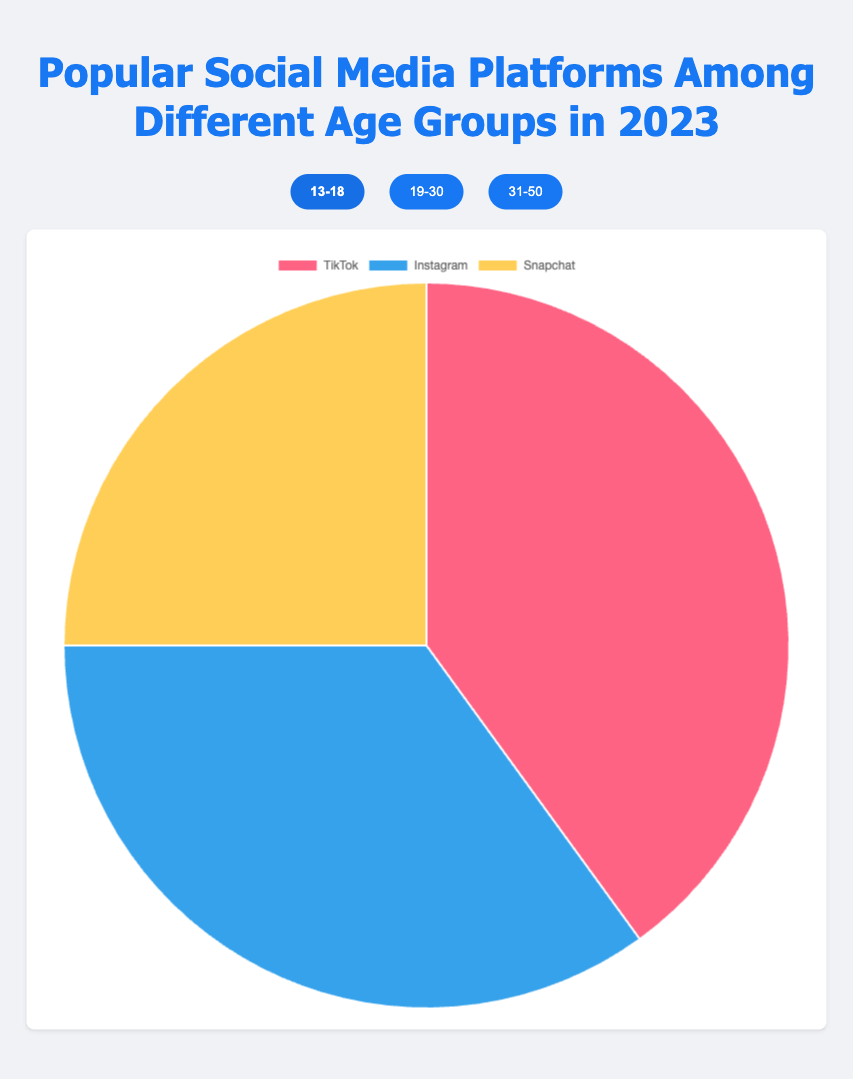Which social media platform is the most popular among the 13-18 age group? In the pie chart for the 13-18 age group, the largest section is labeled "TikTok" with a percentage of 40%.
Answer: TikTok Which age group has the highest percentage usage of Instagram? By examining the pie charts for all age groups, the 19-30 age group has the largest section for Instagram, labeled with a percentage of 45%.
Answer: 19-30 What is the difference in Facebook usage between the 19-30 and 31-50 age groups? In the pie charts, Facebook usage is 30% in the 19-30 age group and 60% in the 31-50 age group. Subtracting these values: 60% - 30% = 30%.
Answer: 30% What is the combined percentage usage of TikTok and Snapchat among the 13-18 age group? In the 13-18 age group pie chart, TikTok is 40% and Snapchat is 25%. Adding these values: 40% + 25% = 65%.
Answer: 65% Which platform has the least usage among the 31-50 age group? In the pie chart for the 31-50 age group, the smallest section is labeled "LinkedIn" with a percentage of 15%.
Answer: LinkedIn Compare the percentage of Instagram usage between the 13-18 and 31-50 age groups. Which age group has higher usage, and by how much? The pie chart shows Instagram usage is 35% for the 13-18 age group and 25% for the 31-50 age group. The difference is 35% - 25% = 10%.
Answer: 13-18 by 10% For the age group 19-30, which two platforms together account for over half of the total usage? In the 19-30 age group, Instagram is 45% and Facebook is 30%. Adding these values: 45% + 30% = 75%, which is over half of the total.
Answer: Instagram and Facebook What is the average percentage of usage of the top three platforms among the 31-50 age group? Among the 31-50 age group, the percentages are Facebook 60%, Instagram 25%, and LinkedIn 15%. The average is (60% + 25% + 15%) / 3 = 33.33%.
Answer: 33.33% How does Snapchat usage in the 13-18 age group compare to LinkedIn usage in the 31-50 age group? In the 13-18 age group, Snapchat usage is 25%, and LinkedIn usage in the 31-50 age group is 15%. Comparing these: 25% > 15%.
Answer: Snapchat usage is higher by 10% What is the total percentage for the usage of all platforms in the 19-30 age group? By adding the percentages of the platforms in the 19-30 age group: Instagram 45% + Facebook 30% + TikTok 25% = 100%.
Answer: 100% 